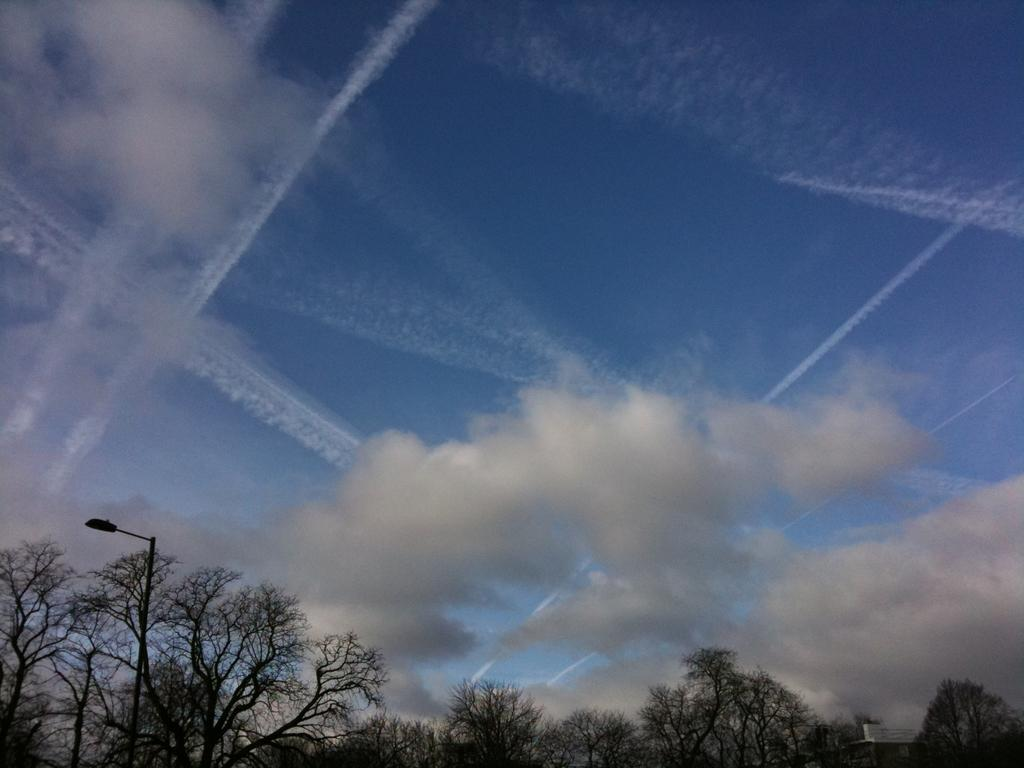What type of vegetation is present in the image? There are many trees in the image. What man-made object can be seen in the image? There is a light pole in the image. What can be seen in the background of the image? There are clouds visible in the background of the image, and the sky is blue. What type of fiction is being read by the tree in the image? There is no tree reading fiction in the image, as trees are not capable of reading. How low is the body of the light pole in the image? The light pole in the image does not have a body, as it is a stationary object. 